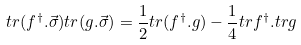<formula> <loc_0><loc_0><loc_500><loc_500>t r ( f ^ { \dag } . \vec { \sigma } ) t r ( g . \vec { \sigma } ) = \frac { 1 } { 2 } t r ( f ^ { \dag } . g ) - \frac { 1 } { 4 } t r f ^ { \dag } . t r g</formula> 